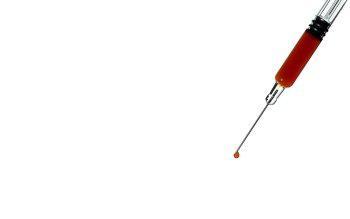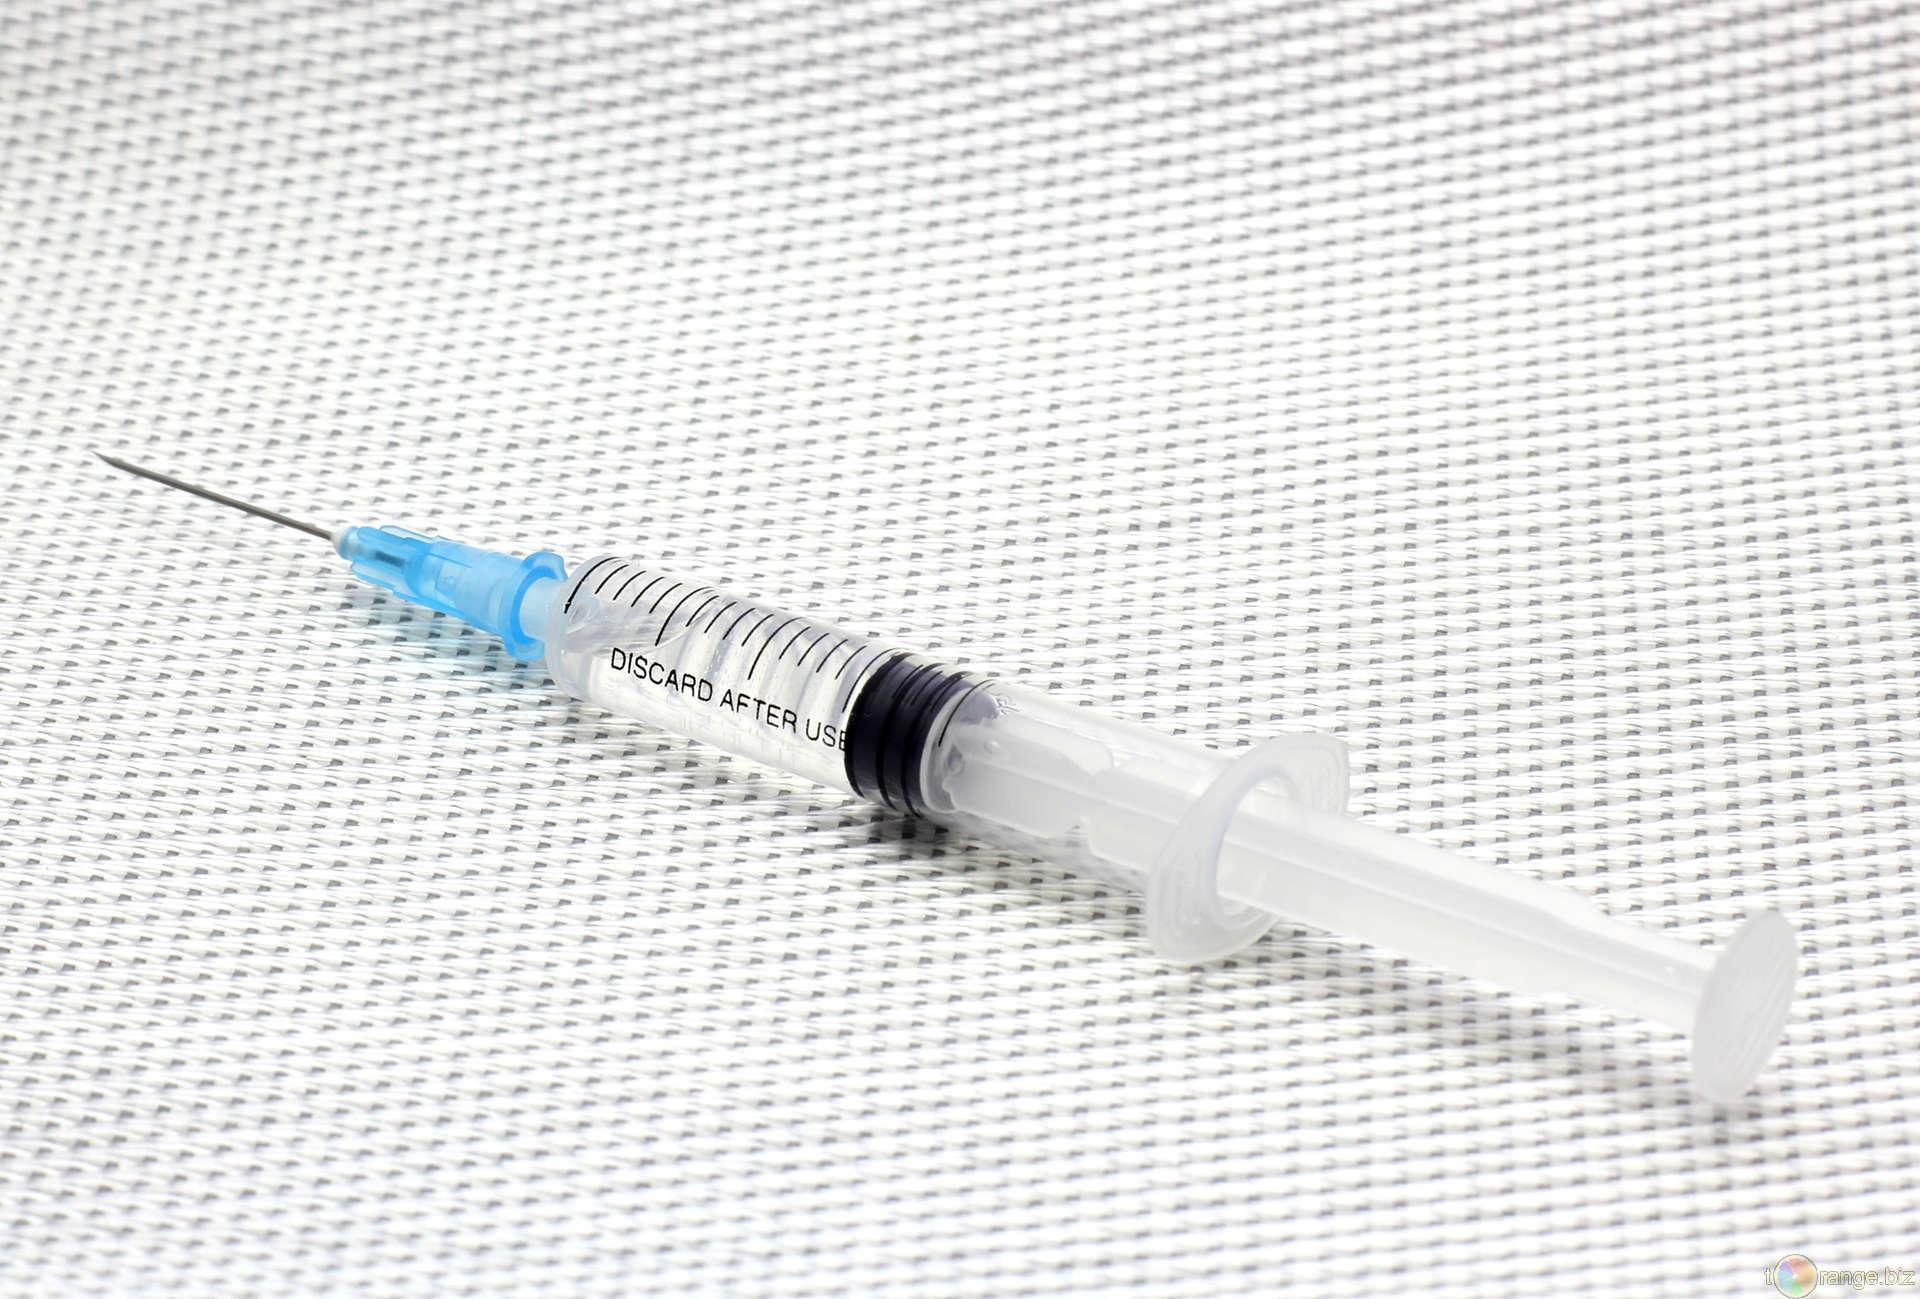The first image is the image on the left, the second image is the image on the right. For the images displayed, is the sentence "In at least one image there is a single syringe being held pointing up and left." factually correct? Answer yes or no. No. The first image is the image on the left, the second image is the image on the right. Given the left and right images, does the statement "A syringe is laying on a table." hold true? Answer yes or no. Yes. 